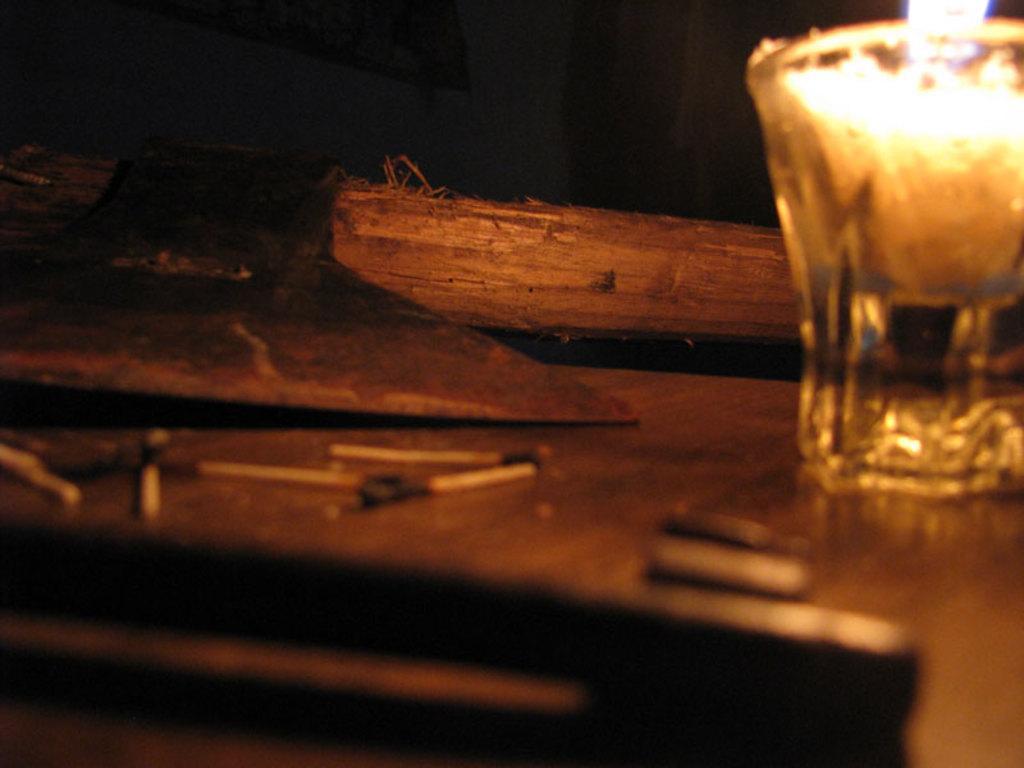Could you give a brief overview of what you see in this image? In this image, at the bottom there is a table on that there is a glass, candle, light, wooden sticks, matchsticks. 